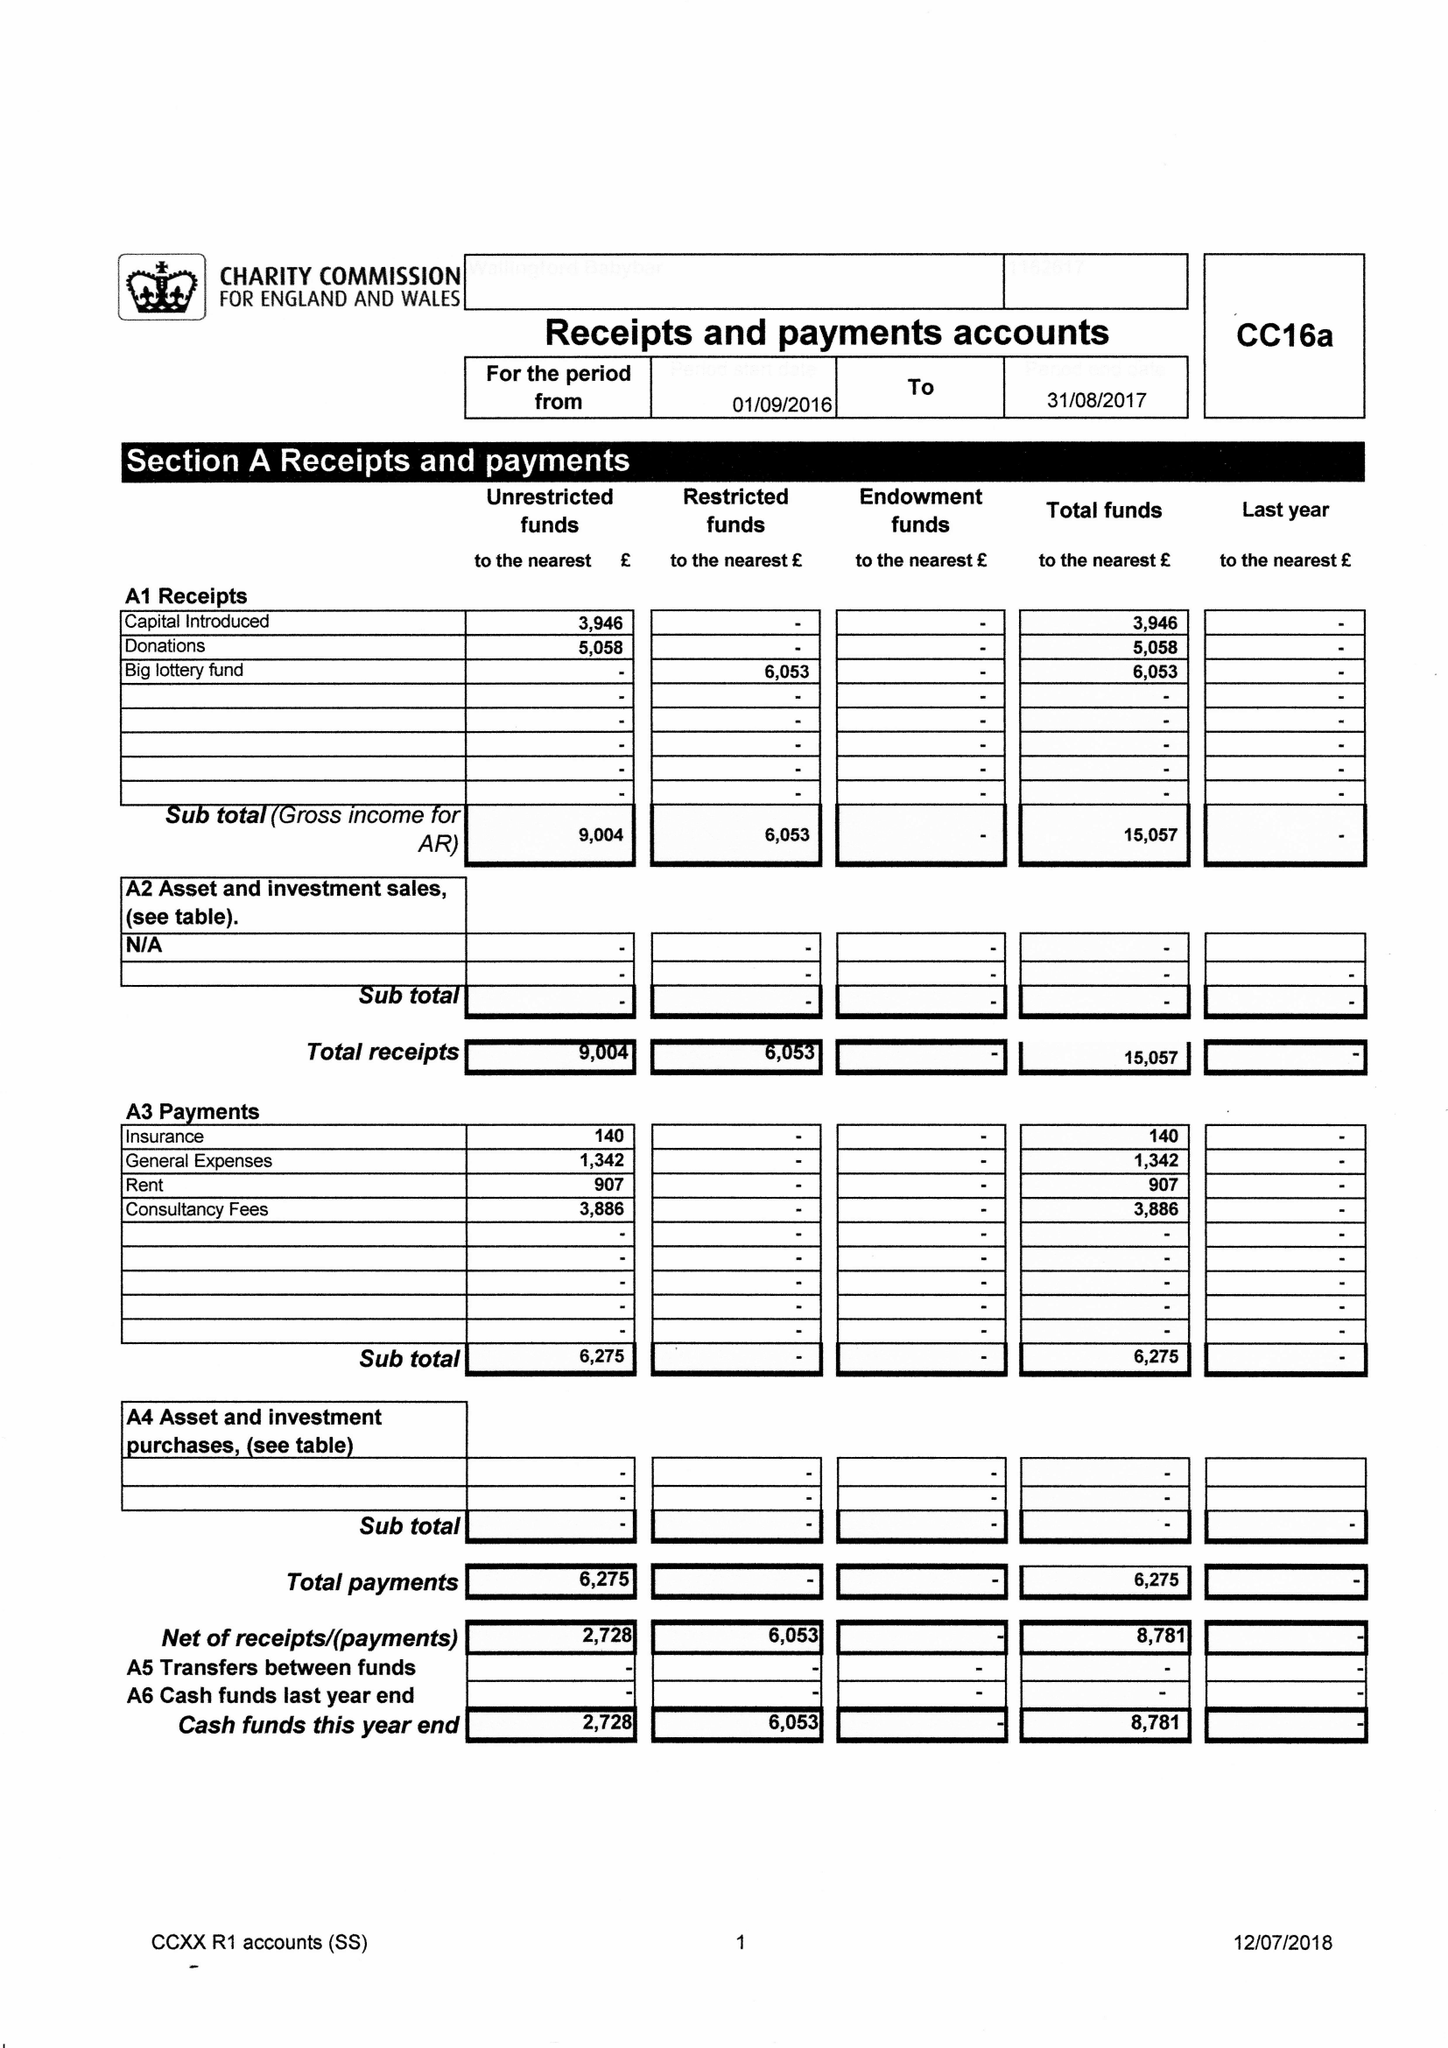What is the value for the charity_name?
Answer the question using a single word or phrase. Wallingford Baby Bar 